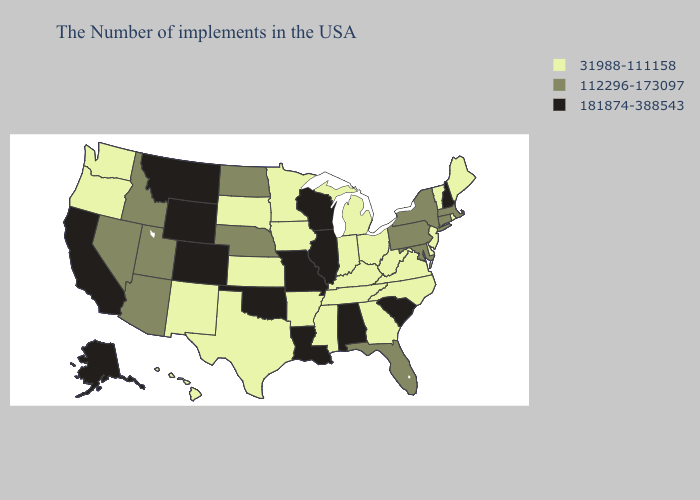What is the lowest value in states that border Minnesota?
Write a very short answer. 31988-111158. Name the states that have a value in the range 112296-173097?
Quick response, please. Massachusetts, Connecticut, New York, Maryland, Pennsylvania, Florida, Nebraska, North Dakota, Utah, Arizona, Idaho, Nevada. Does Tennessee have the same value as Maryland?
Give a very brief answer. No. What is the highest value in states that border Rhode Island?
Quick response, please. 112296-173097. Name the states that have a value in the range 31988-111158?
Give a very brief answer. Maine, Rhode Island, Vermont, New Jersey, Delaware, Virginia, North Carolina, West Virginia, Ohio, Georgia, Michigan, Kentucky, Indiana, Tennessee, Mississippi, Arkansas, Minnesota, Iowa, Kansas, Texas, South Dakota, New Mexico, Washington, Oregon, Hawaii. What is the value of Connecticut?
Keep it brief. 112296-173097. What is the highest value in the Northeast ?
Concise answer only. 181874-388543. Name the states that have a value in the range 31988-111158?
Concise answer only. Maine, Rhode Island, Vermont, New Jersey, Delaware, Virginia, North Carolina, West Virginia, Ohio, Georgia, Michigan, Kentucky, Indiana, Tennessee, Mississippi, Arkansas, Minnesota, Iowa, Kansas, Texas, South Dakota, New Mexico, Washington, Oregon, Hawaii. What is the value of Missouri?
Quick response, please. 181874-388543. Does the map have missing data?
Answer briefly. No. What is the highest value in the South ?
Be succinct. 181874-388543. What is the highest value in the USA?
Give a very brief answer. 181874-388543. What is the lowest value in states that border Mississippi?
Concise answer only. 31988-111158. Does the map have missing data?
Quick response, please. No. Among the states that border Alabama , does Florida have the highest value?
Write a very short answer. Yes. 